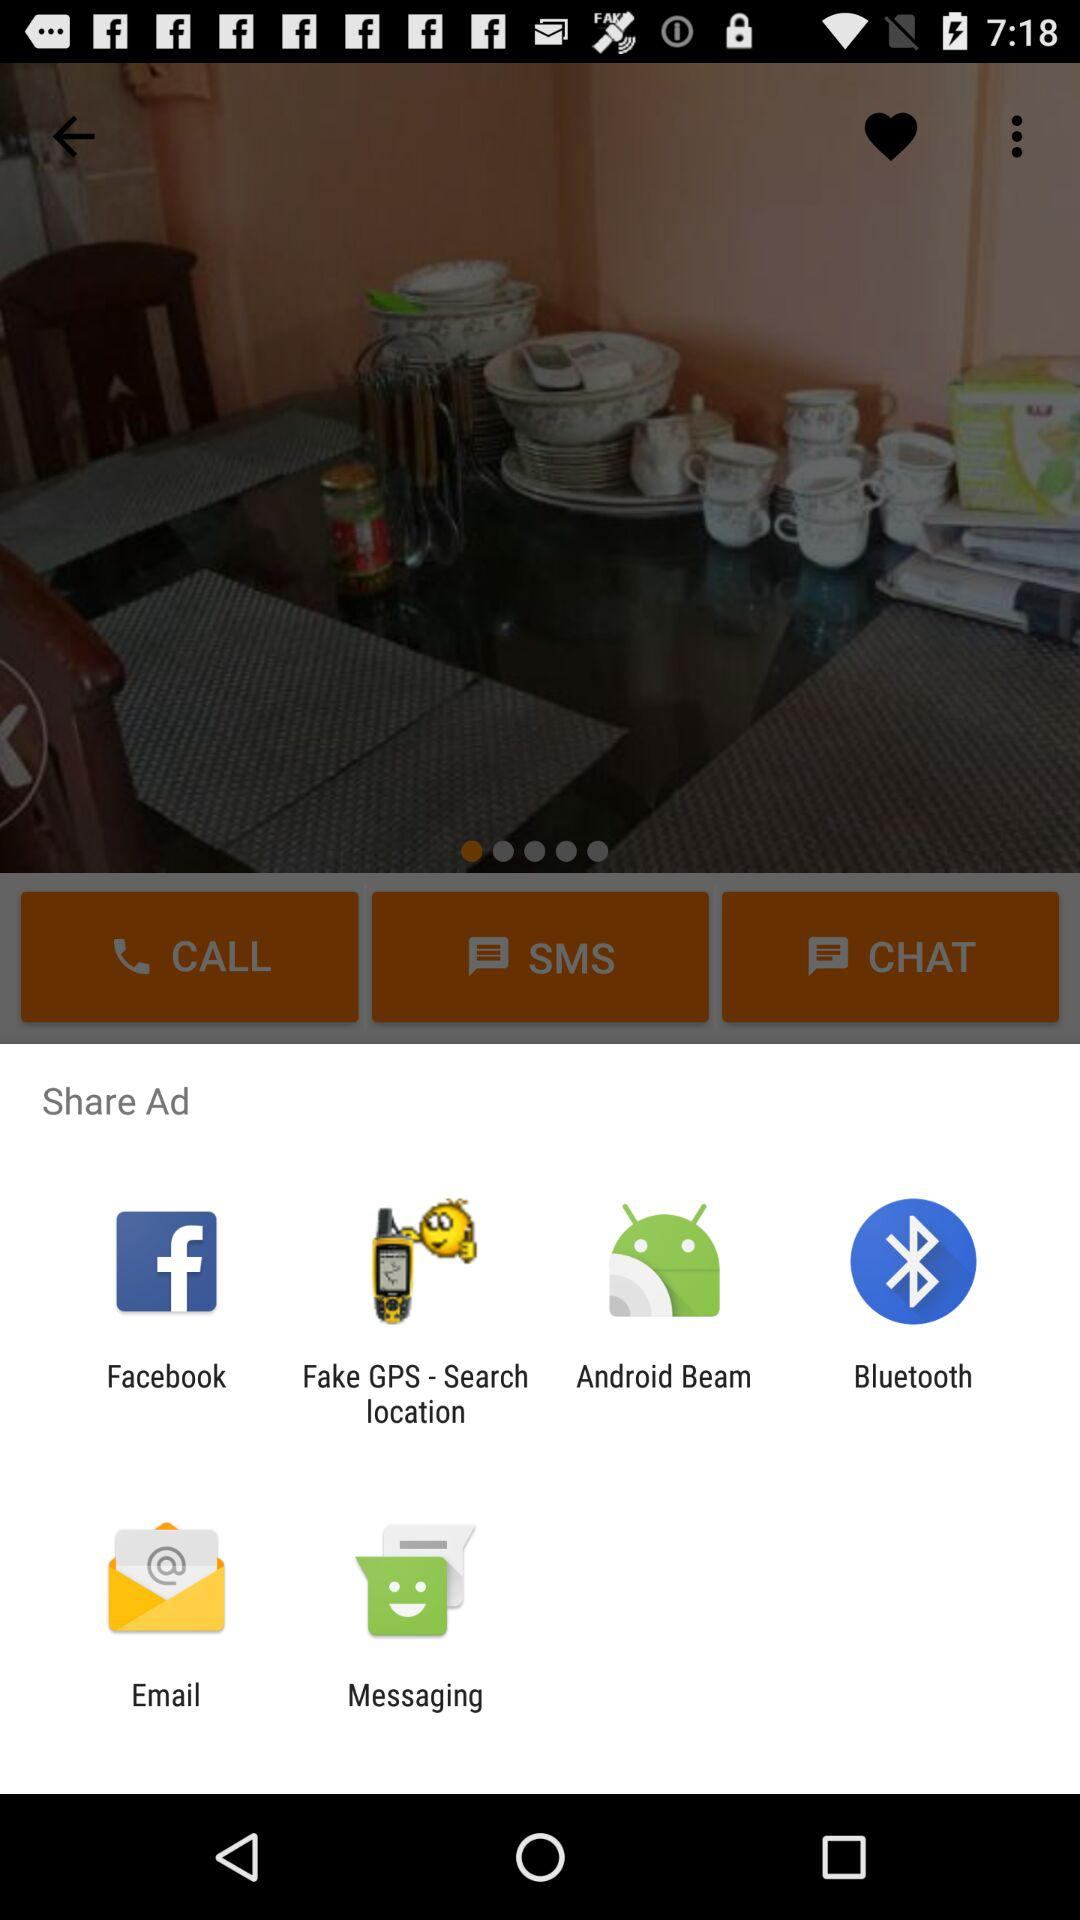What are the options to share? The options to share are "Facebook", "Fake GPS - Search location", "Android Beam", "Bluetooth", "Email" and "Messaging". 